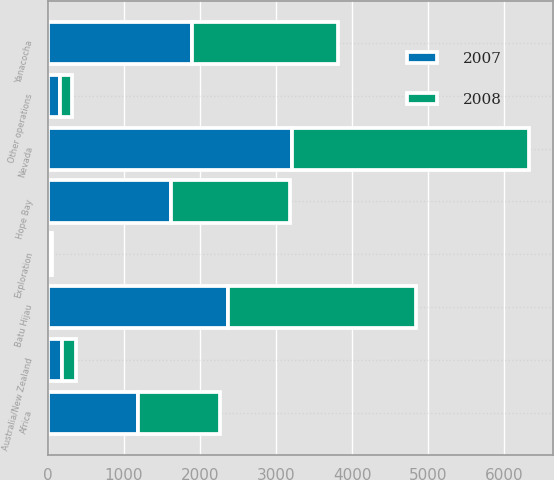<chart> <loc_0><loc_0><loc_500><loc_500><stacked_bar_chart><ecel><fcel>Australia/New Zealand<fcel>Nevada<fcel>Yanacocha<fcel>Batu Hijau<fcel>Africa<fcel>Hope Bay<fcel>Other operations<fcel>Exploration<nl><fcel>2007<fcel>188<fcel>3215<fcel>1902<fcel>2371<fcel>1181<fcel>1621<fcel>166<fcel>37<nl><fcel>2008<fcel>186<fcel>3104<fcel>1908<fcel>2471<fcel>1082<fcel>1566<fcel>157<fcel>24<nl></chart> 